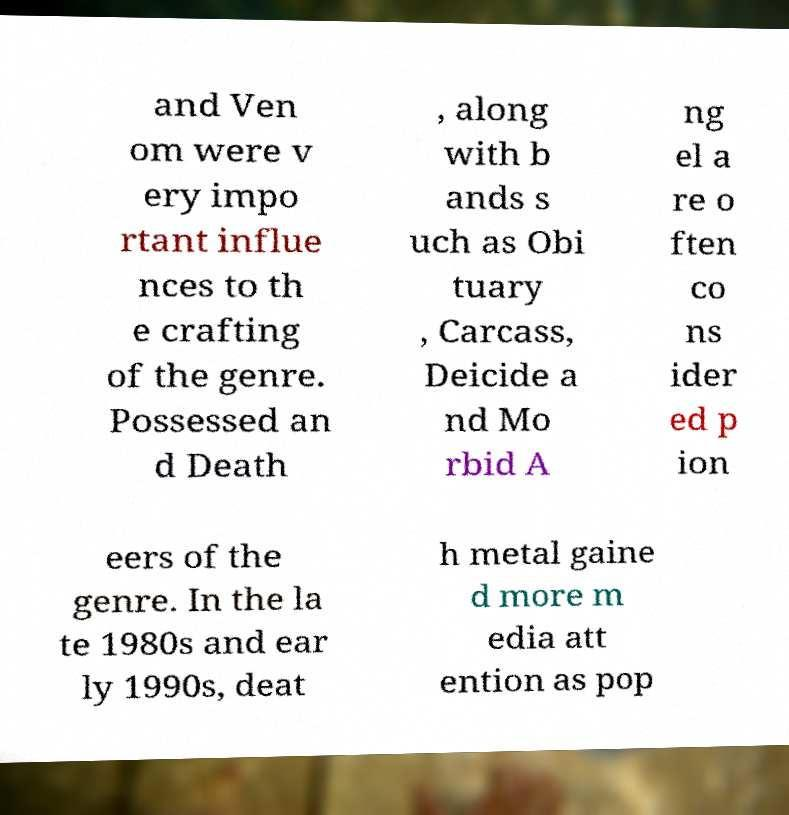Could you extract and type out the text from this image? and Ven om were v ery impo rtant influe nces to th e crafting of the genre. Possessed an d Death , along with b ands s uch as Obi tuary , Carcass, Deicide a nd Mo rbid A ng el a re o ften co ns ider ed p ion eers of the genre. In the la te 1980s and ear ly 1990s, deat h metal gaine d more m edia att ention as pop 